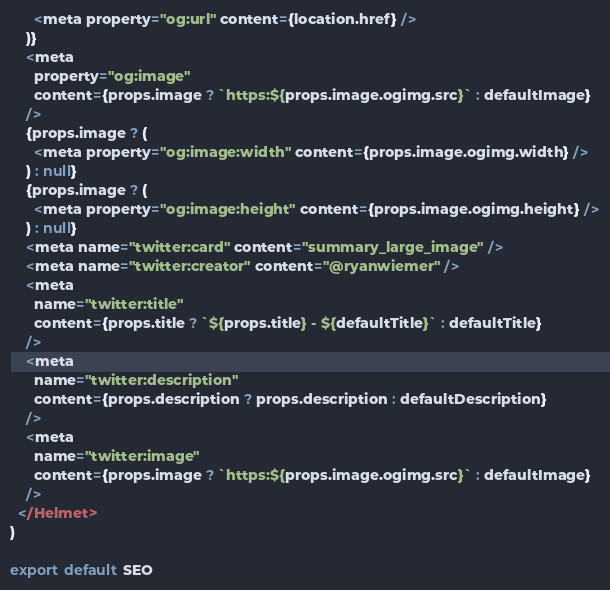Convert code to text. <code><loc_0><loc_0><loc_500><loc_500><_JavaScript_>      <meta property="og:url" content={location.href} />
    )}
    <meta
      property="og:image"
      content={props.image ? `https:${props.image.ogimg.src}` : defaultImage}
    />
    {props.image ? (
      <meta property="og:image:width" content={props.image.ogimg.width} />
    ) : null}
    {props.image ? (
      <meta property="og:image:height" content={props.image.ogimg.height} />
    ) : null}
    <meta name="twitter:card" content="summary_large_image" />
    <meta name="twitter:creator" content="@ryanwiemer" />
    <meta
      name="twitter:title"
      content={props.title ? `${props.title} - ${defaultTitle}` : defaultTitle}
    />
    <meta
      name="twitter:description"
      content={props.description ? props.description : defaultDescription}
    />
    <meta
      name="twitter:image"
      content={props.image ? `https:${props.image.ogimg.src}` : defaultImage}
    />
  </Helmet>
)

export default SEO
</code> 